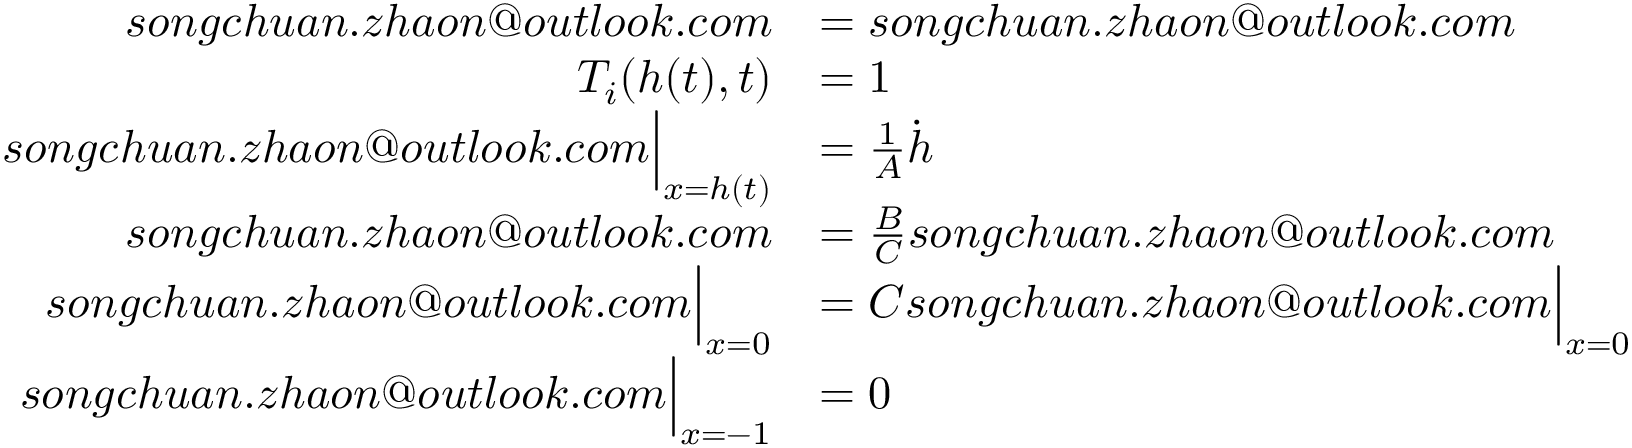Convert formula to latex. <formula><loc_0><loc_0><loc_500><loc_500>\begin{array} { r l } { s o n g c h u a n . z h a o n o u t l o o k . c o m } & { = s o n g c h u a n . z h a o n o u t l o o k . c o m } \\ { { T _ { i } } ( { h } ( t ) , t ) } & { = 1 } \\ { s o n g c h u a n . z h a o n o u t l o o k . c o m \left | _ { x = h ( t ) } } & { = \frac { 1 } { A } \dot { h } } \\ { s o n g c h u a n . z h a o n o u t l o o k . c o m } & { = \frac { B } { C } s o n g c h u a n . z h a o n o u t l o o k . c o m } \\ { s o n g c h u a n . z h a o n o u t l o o k . c o m \right | _ { x = 0 } } & { = C s o n g c h u a n . z h a o n o u t l o o k . c o m \left | _ { x = 0 } } \\ { s o n g c h u a n . z h a o n o u t l o o k . c o m \right | _ { x = - 1 } } & { = 0 } \end{array}</formula> 